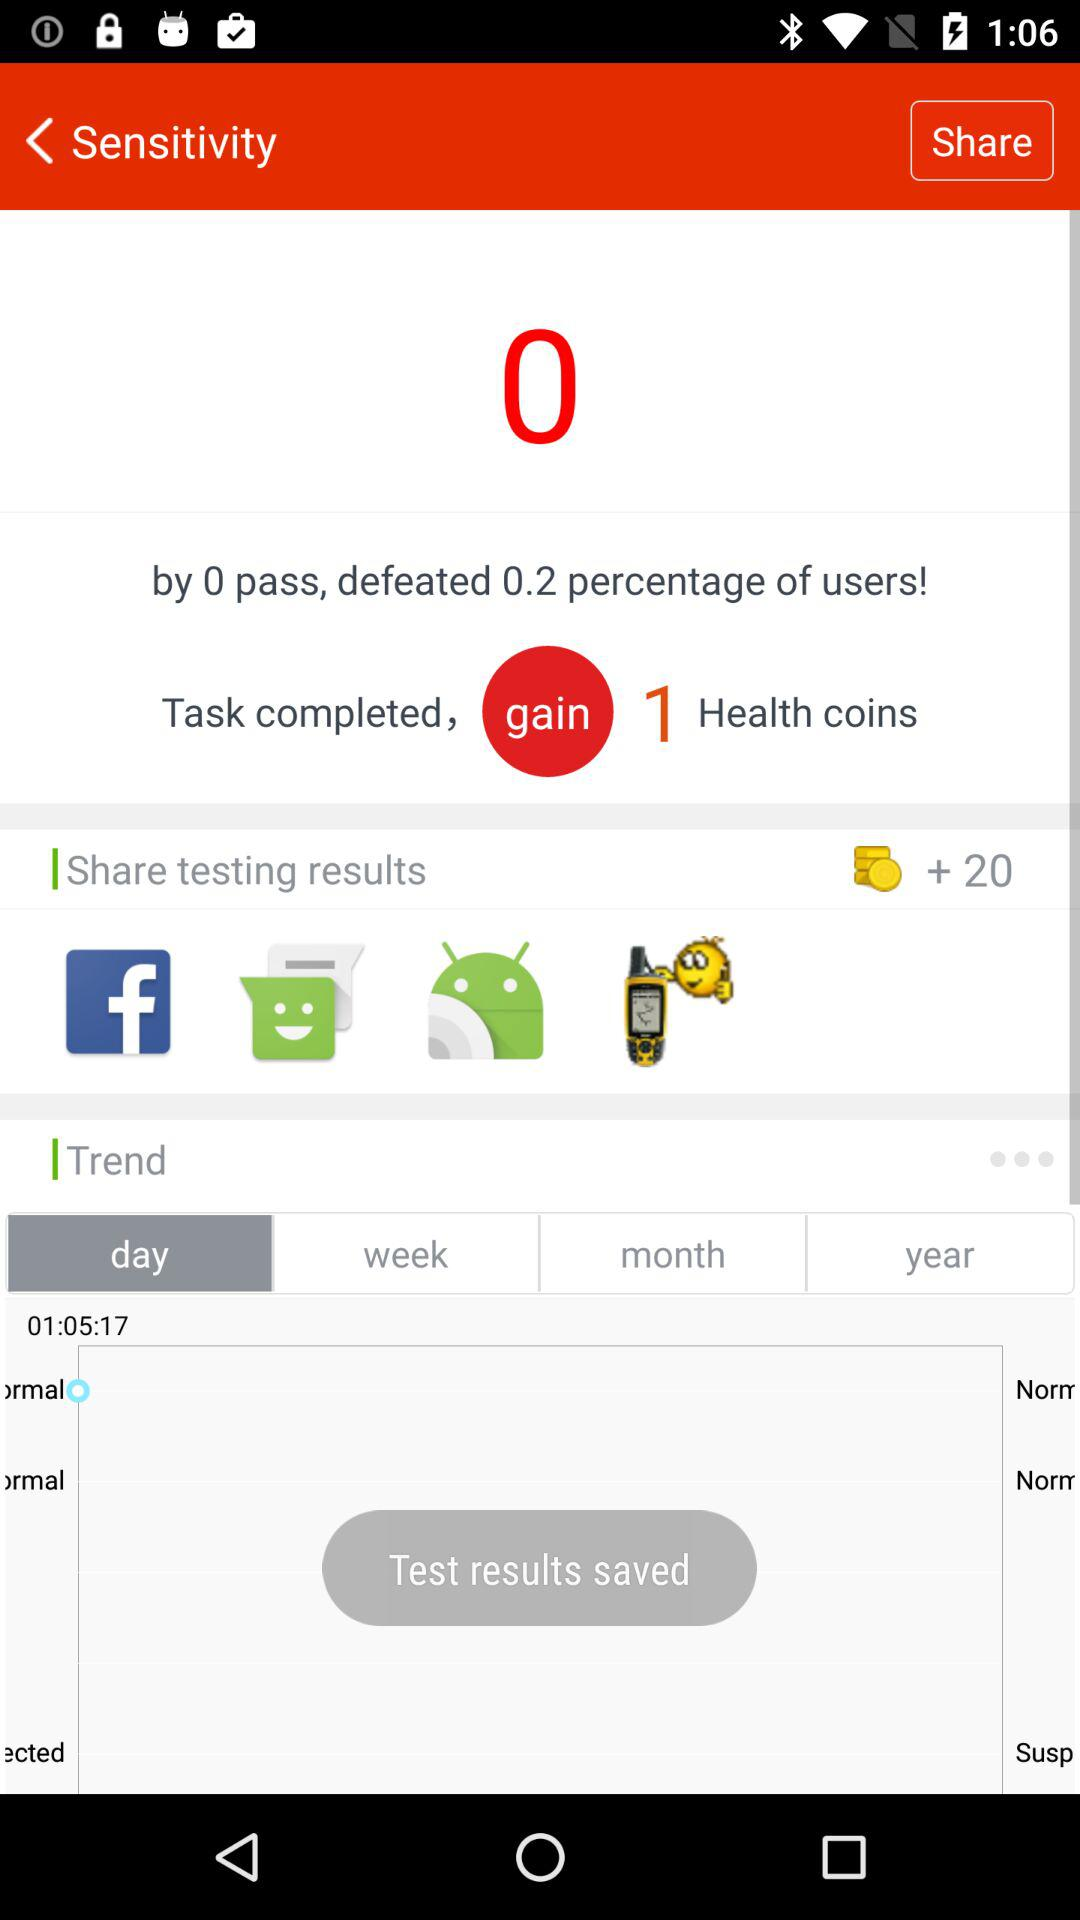What is the total number of coins? The total number of coins is 20. 